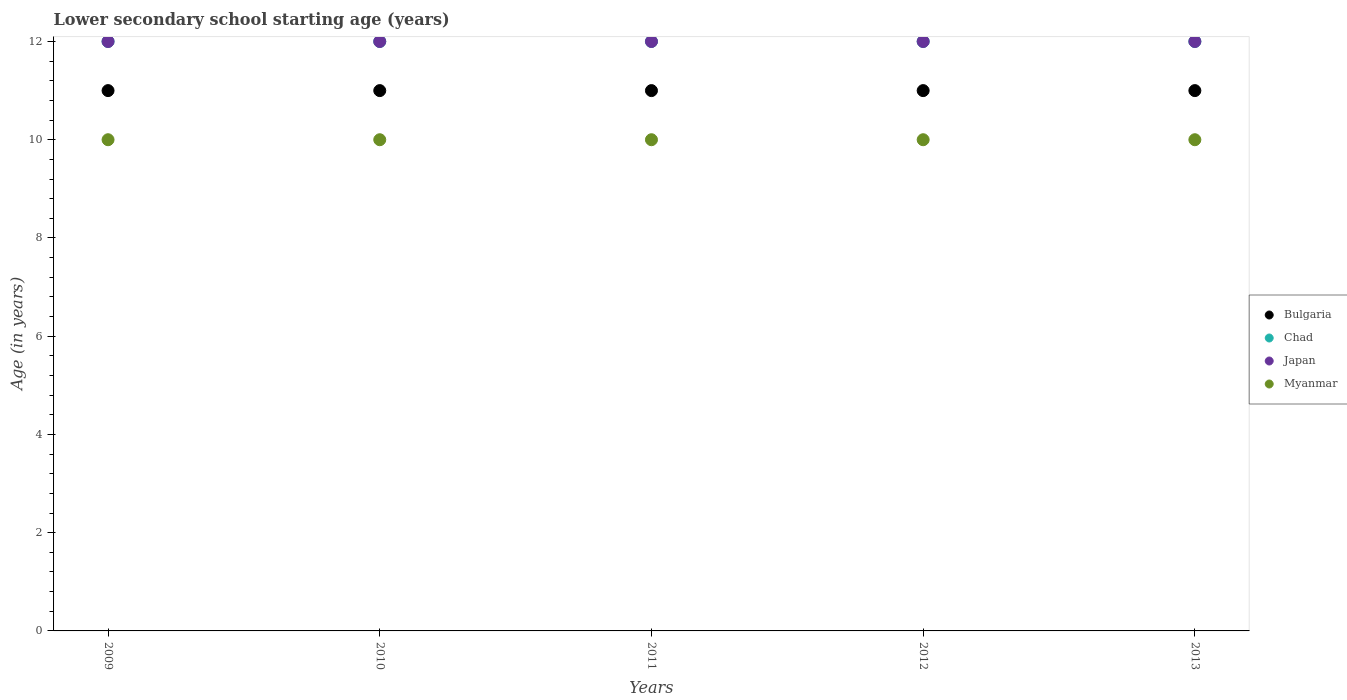How many different coloured dotlines are there?
Provide a succinct answer. 4. What is the lower secondary school starting age of children in Bulgaria in 2009?
Ensure brevity in your answer.  11. Across all years, what is the maximum lower secondary school starting age of children in Chad?
Keep it short and to the point. 12. Across all years, what is the minimum lower secondary school starting age of children in Bulgaria?
Your answer should be very brief. 11. In which year was the lower secondary school starting age of children in Chad maximum?
Your answer should be compact. 2009. In which year was the lower secondary school starting age of children in Myanmar minimum?
Ensure brevity in your answer.  2009. What is the total lower secondary school starting age of children in Chad in the graph?
Keep it short and to the point. 60. What is the difference between the lower secondary school starting age of children in Chad in 2010 and that in 2011?
Keep it short and to the point. 0. What is the difference between the lower secondary school starting age of children in Bulgaria in 2013 and the lower secondary school starting age of children in Chad in 2012?
Your response must be concise. -1. In the year 2013, what is the difference between the lower secondary school starting age of children in Bulgaria and lower secondary school starting age of children in Japan?
Provide a short and direct response. -1. In how many years, is the lower secondary school starting age of children in Bulgaria greater than 4.8 years?
Your response must be concise. 5. What is the ratio of the lower secondary school starting age of children in Bulgaria in 2009 to that in 2012?
Offer a terse response. 1. In how many years, is the lower secondary school starting age of children in Bulgaria greater than the average lower secondary school starting age of children in Bulgaria taken over all years?
Give a very brief answer. 0. Is the sum of the lower secondary school starting age of children in Japan in 2010 and 2011 greater than the maximum lower secondary school starting age of children in Chad across all years?
Provide a short and direct response. Yes. Is it the case that in every year, the sum of the lower secondary school starting age of children in Myanmar and lower secondary school starting age of children in Bulgaria  is greater than the lower secondary school starting age of children in Chad?
Offer a terse response. Yes. Does the lower secondary school starting age of children in Bulgaria monotonically increase over the years?
Offer a very short reply. No. How many dotlines are there?
Keep it short and to the point. 4. How many years are there in the graph?
Provide a short and direct response. 5. What is the difference between two consecutive major ticks on the Y-axis?
Provide a succinct answer. 2. What is the title of the graph?
Your response must be concise. Lower secondary school starting age (years). What is the label or title of the Y-axis?
Keep it short and to the point. Age (in years). What is the Age (in years) in Bulgaria in 2009?
Offer a very short reply. 11. What is the Age (in years) in Japan in 2009?
Your answer should be very brief. 12. What is the Age (in years) of Myanmar in 2009?
Provide a short and direct response. 10. What is the Age (in years) of Chad in 2011?
Your answer should be compact. 12. What is the Age (in years) of Bulgaria in 2012?
Your answer should be very brief. 11. What is the Age (in years) in Bulgaria in 2013?
Provide a succinct answer. 11. Across all years, what is the maximum Age (in years) of Myanmar?
Keep it short and to the point. 10. Across all years, what is the minimum Age (in years) of Chad?
Ensure brevity in your answer.  12. What is the total Age (in years) of Chad in the graph?
Provide a short and direct response. 60. What is the difference between the Age (in years) in Bulgaria in 2009 and that in 2010?
Your answer should be very brief. 0. What is the difference between the Age (in years) in Japan in 2009 and that in 2010?
Your response must be concise. 0. What is the difference between the Age (in years) of Chad in 2009 and that in 2011?
Make the answer very short. 0. What is the difference between the Age (in years) in Japan in 2009 and that in 2011?
Ensure brevity in your answer.  0. What is the difference between the Age (in years) in Chad in 2009 and that in 2012?
Your response must be concise. 0. What is the difference between the Age (in years) of Myanmar in 2009 and that in 2012?
Your response must be concise. 0. What is the difference between the Age (in years) of Chad in 2009 and that in 2013?
Provide a succinct answer. 0. What is the difference between the Age (in years) in Bulgaria in 2010 and that in 2011?
Provide a short and direct response. 0. What is the difference between the Age (in years) of Chad in 2010 and that in 2011?
Your answer should be compact. 0. What is the difference between the Age (in years) in Myanmar in 2010 and that in 2011?
Ensure brevity in your answer.  0. What is the difference between the Age (in years) in Japan in 2010 and that in 2012?
Your answer should be compact. 0. What is the difference between the Age (in years) of Bulgaria in 2010 and that in 2013?
Keep it short and to the point. 0. What is the difference between the Age (in years) of Japan in 2010 and that in 2013?
Provide a succinct answer. 0. What is the difference between the Age (in years) in Myanmar in 2010 and that in 2013?
Keep it short and to the point. 0. What is the difference between the Age (in years) of Bulgaria in 2011 and that in 2012?
Ensure brevity in your answer.  0. What is the difference between the Age (in years) in Myanmar in 2011 and that in 2012?
Provide a succinct answer. 0. What is the difference between the Age (in years) in Bulgaria in 2011 and that in 2013?
Offer a very short reply. 0. What is the difference between the Age (in years) of Japan in 2011 and that in 2013?
Ensure brevity in your answer.  0. What is the difference between the Age (in years) of Myanmar in 2012 and that in 2013?
Make the answer very short. 0. What is the difference between the Age (in years) of Japan in 2009 and the Age (in years) of Myanmar in 2010?
Offer a terse response. 2. What is the difference between the Age (in years) in Bulgaria in 2009 and the Age (in years) in Japan in 2011?
Ensure brevity in your answer.  -1. What is the difference between the Age (in years) in Bulgaria in 2009 and the Age (in years) in Myanmar in 2011?
Your response must be concise. 1. What is the difference between the Age (in years) of Chad in 2009 and the Age (in years) of Myanmar in 2011?
Provide a succinct answer. 2. What is the difference between the Age (in years) of Bulgaria in 2009 and the Age (in years) of Chad in 2012?
Offer a very short reply. -1. What is the difference between the Age (in years) in Bulgaria in 2009 and the Age (in years) in Myanmar in 2012?
Ensure brevity in your answer.  1. What is the difference between the Age (in years) of Chad in 2009 and the Age (in years) of Myanmar in 2012?
Offer a very short reply. 2. What is the difference between the Age (in years) in Japan in 2009 and the Age (in years) in Myanmar in 2012?
Make the answer very short. 2. What is the difference between the Age (in years) in Bulgaria in 2009 and the Age (in years) in Chad in 2013?
Ensure brevity in your answer.  -1. What is the difference between the Age (in years) of Chad in 2009 and the Age (in years) of Japan in 2013?
Offer a very short reply. 0. What is the difference between the Age (in years) of Bulgaria in 2010 and the Age (in years) of Chad in 2011?
Your answer should be compact. -1. What is the difference between the Age (in years) in Bulgaria in 2010 and the Age (in years) in Myanmar in 2011?
Keep it short and to the point. 1. What is the difference between the Age (in years) in Chad in 2010 and the Age (in years) in Japan in 2011?
Offer a terse response. 0. What is the difference between the Age (in years) in Japan in 2010 and the Age (in years) in Myanmar in 2011?
Your answer should be compact. 2. What is the difference between the Age (in years) of Bulgaria in 2010 and the Age (in years) of Japan in 2012?
Make the answer very short. -1. What is the difference between the Age (in years) in Bulgaria in 2010 and the Age (in years) in Myanmar in 2012?
Make the answer very short. 1. What is the difference between the Age (in years) of Chad in 2010 and the Age (in years) of Myanmar in 2012?
Make the answer very short. 2. What is the difference between the Age (in years) in Bulgaria in 2010 and the Age (in years) in Japan in 2013?
Make the answer very short. -1. What is the difference between the Age (in years) of Chad in 2010 and the Age (in years) of Japan in 2013?
Your answer should be very brief. 0. What is the difference between the Age (in years) in Chad in 2010 and the Age (in years) in Myanmar in 2013?
Your answer should be compact. 2. What is the difference between the Age (in years) in Japan in 2010 and the Age (in years) in Myanmar in 2013?
Your response must be concise. 2. What is the difference between the Age (in years) in Bulgaria in 2011 and the Age (in years) in Chad in 2012?
Provide a short and direct response. -1. What is the difference between the Age (in years) in Chad in 2011 and the Age (in years) in Myanmar in 2012?
Your answer should be compact. 2. What is the difference between the Age (in years) of Japan in 2011 and the Age (in years) of Myanmar in 2012?
Provide a short and direct response. 2. What is the difference between the Age (in years) in Bulgaria in 2011 and the Age (in years) in Japan in 2013?
Provide a succinct answer. -1. What is the difference between the Age (in years) in Chad in 2011 and the Age (in years) in Japan in 2013?
Make the answer very short. 0. What is the difference between the Age (in years) in Japan in 2011 and the Age (in years) in Myanmar in 2013?
Keep it short and to the point. 2. What is the difference between the Age (in years) in Bulgaria in 2012 and the Age (in years) in Japan in 2013?
Offer a very short reply. -1. What is the difference between the Age (in years) in Bulgaria in 2012 and the Age (in years) in Myanmar in 2013?
Make the answer very short. 1. What is the difference between the Age (in years) of Chad in 2012 and the Age (in years) of Myanmar in 2013?
Your answer should be compact. 2. What is the average Age (in years) of Bulgaria per year?
Provide a succinct answer. 11. What is the average Age (in years) in Chad per year?
Your answer should be very brief. 12. What is the average Age (in years) in Japan per year?
Provide a short and direct response. 12. What is the average Age (in years) in Myanmar per year?
Provide a succinct answer. 10. In the year 2009, what is the difference between the Age (in years) of Bulgaria and Age (in years) of Chad?
Give a very brief answer. -1. In the year 2009, what is the difference between the Age (in years) in Bulgaria and Age (in years) in Myanmar?
Provide a succinct answer. 1. In the year 2009, what is the difference between the Age (in years) in Japan and Age (in years) in Myanmar?
Your answer should be compact. 2. In the year 2010, what is the difference between the Age (in years) in Bulgaria and Age (in years) in Myanmar?
Offer a very short reply. 1. In the year 2010, what is the difference between the Age (in years) of Chad and Age (in years) of Japan?
Keep it short and to the point. 0. In the year 2011, what is the difference between the Age (in years) in Bulgaria and Age (in years) in Chad?
Give a very brief answer. -1. In the year 2011, what is the difference between the Age (in years) of Bulgaria and Age (in years) of Japan?
Provide a short and direct response. -1. In the year 2011, what is the difference between the Age (in years) of Bulgaria and Age (in years) of Myanmar?
Make the answer very short. 1. In the year 2011, what is the difference between the Age (in years) in Chad and Age (in years) in Japan?
Give a very brief answer. 0. In the year 2011, what is the difference between the Age (in years) in Chad and Age (in years) in Myanmar?
Offer a terse response. 2. In the year 2012, what is the difference between the Age (in years) of Bulgaria and Age (in years) of Japan?
Your response must be concise. -1. In the year 2012, what is the difference between the Age (in years) in Bulgaria and Age (in years) in Myanmar?
Your answer should be compact. 1. In the year 2012, what is the difference between the Age (in years) in Chad and Age (in years) in Myanmar?
Provide a succinct answer. 2. In the year 2012, what is the difference between the Age (in years) of Japan and Age (in years) of Myanmar?
Give a very brief answer. 2. In the year 2013, what is the difference between the Age (in years) in Bulgaria and Age (in years) in Japan?
Ensure brevity in your answer.  -1. In the year 2013, what is the difference between the Age (in years) of Chad and Age (in years) of Japan?
Ensure brevity in your answer.  0. In the year 2013, what is the difference between the Age (in years) of Chad and Age (in years) of Myanmar?
Your answer should be compact. 2. In the year 2013, what is the difference between the Age (in years) of Japan and Age (in years) of Myanmar?
Provide a short and direct response. 2. What is the ratio of the Age (in years) in Bulgaria in 2009 to that in 2010?
Keep it short and to the point. 1. What is the ratio of the Age (in years) of Chad in 2009 to that in 2010?
Offer a terse response. 1. What is the ratio of the Age (in years) in Chad in 2009 to that in 2011?
Offer a terse response. 1. What is the ratio of the Age (in years) in Myanmar in 2009 to that in 2011?
Offer a terse response. 1. What is the ratio of the Age (in years) in Bulgaria in 2009 to that in 2012?
Offer a very short reply. 1. What is the ratio of the Age (in years) in Chad in 2009 to that in 2012?
Keep it short and to the point. 1. What is the ratio of the Age (in years) of Myanmar in 2009 to that in 2012?
Offer a very short reply. 1. What is the ratio of the Age (in years) in Japan in 2009 to that in 2013?
Give a very brief answer. 1. What is the ratio of the Age (in years) in Myanmar in 2009 to that in 2013?
Ensure brevity in your answer.  1. What is the ratio of the Age (in years) of Japan in 2010 to that in 2011?
Keep it short and to the point. 1. What is the ratio of the Age (in years) in Myanmar in 2010 to that in 2011?
Keep it short and to the point. 1. What is the ratio of the Age (in years) in Bulgaria in 2010 to that in 2012?
Offer a terse response. 1. What is the ratio of the Age (in years) of Chad in 2010 to that in 2012?
Offer a very short reply. 1. What is the ratio of the Age (in years) of Japan in 2010 to that in 2012?
Make the answer very short. 1. What is the ratio of the Age (in years) of Chad in 2010 to that in 2013?
Your answer should be compact. 1. What is the ratio of the Age (in years) in Myanmar in 2010 to that in 2013?
Your response must be concise. 1. What is the ratio of the Age (in years) in Bulgaria in 2011 to that in 2012?
Keep it short and to the point. 1. What is the ratio of the Age (in years) of Japan in 2011 to that in 2012?
Ensure brevity in your answer.  1. What is the ratio of the Age (in years) of Myanmar in 2011 to that in 2012?
Your answer should be compact. 1. What is the ratio of the Age (in years) of Japan in 2011 to that in 2013?
Offer a terse response. 1. What is the ratio of the Age (in years) of Myanmar in 2011 to that in 2013?
Make the answer very short. 1. What is the ratio of the Age (in years) in Japan in 2012 to that in 2013?
Offer a very short reply. 1. What is the ratio of the Age (in years) in Myanmar in 2012 to that in 2013?
Ensure brevity in your answer.  1. What is the difference between the highest and the second highest Age (in years) of Bulgaria?
Offer a very short reply. 0. What is the difference between the highest and the lowest Age (in years) of Chad?
Give a very brief answer. 0. What is the difference between the highest and the lowest Age (in years) in Myanmar?
Provide a succinct answer. 0. 